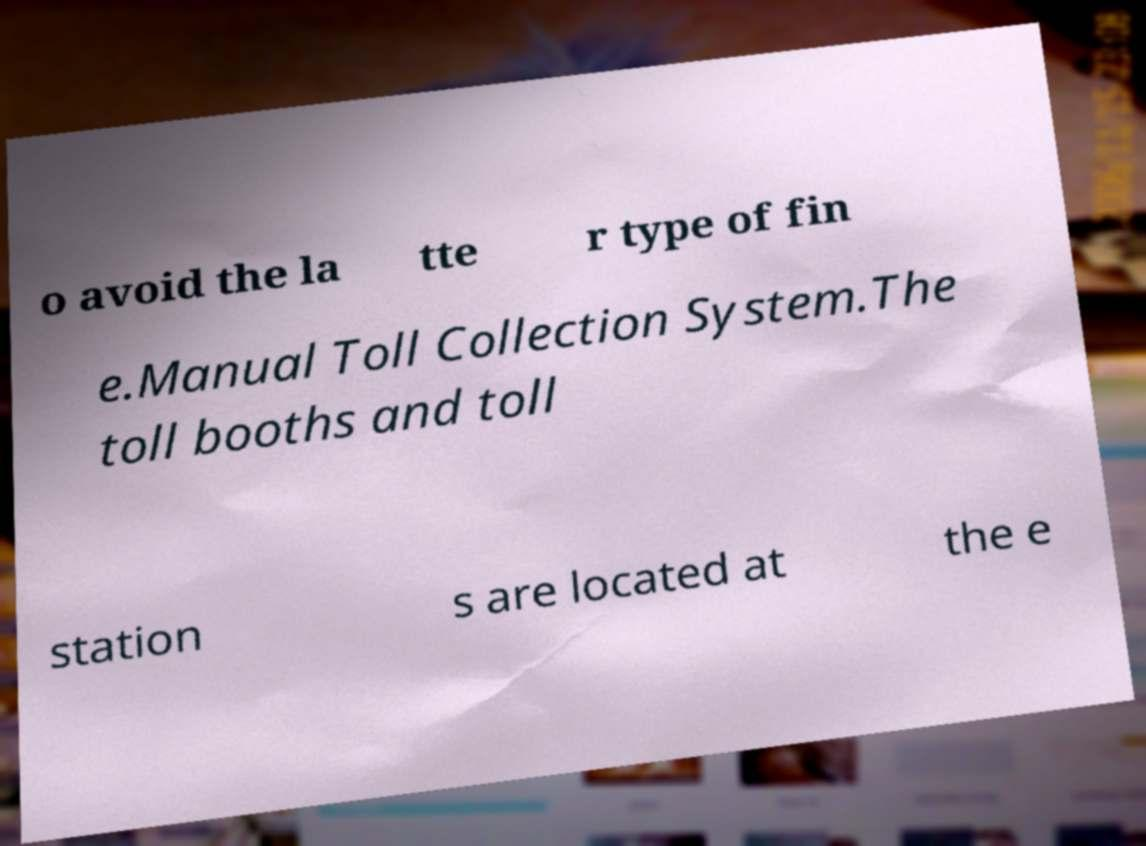Can you read and provide the text displayed in the image?This photo seems to have some interesting text. Can you extract and type it out for me? o avoid the la tte r type of fin e.Manual Toll Collection System.The toll booths and toll station s are located at the e 